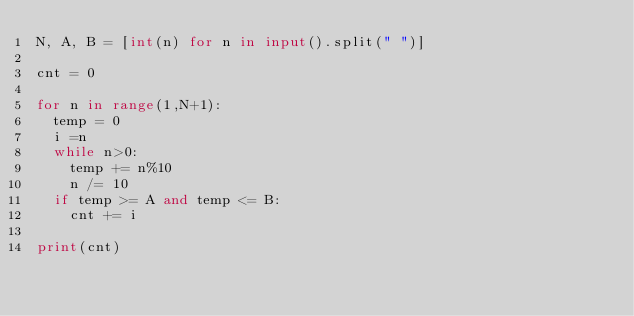Convert code to text. <code><loc_0><loc_0><loc_500><loc_500><_Python_>N, A, B = [int(n) for n in input().split(" ")]

cnt = 0

for n in range(1,N+1):
  temp = 0
  i =n
  while n>0:
    temp += n%10
    n /= 10
  if temp >= A and temp <= B:
    cnt += i

print(cnt)
</code> 